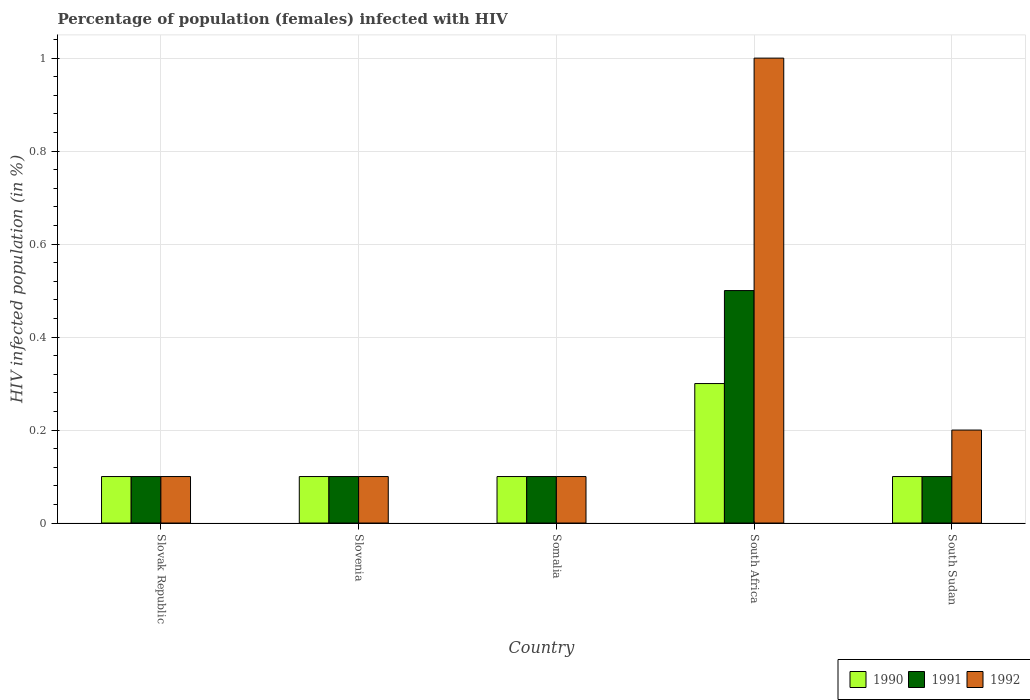How many bars are there on the 3rd tick from the right?
Offer a terse response. 3. What is the label of the 2nd group of bars from the left?
Your answer should be very brief. Slovenia. In how many cases, is the number of bars for a given country not equal to the number of legend labels?
Make the answer very short. 0. In which country was the percentage of HIV infected female population in 1991 maximum?
Your response must be concise. South Africa. In which country was the percentage of HIV infected female population in 1991 minimum?
Make the answer very short. Slovak Republic. What is the total percentage of HIV infected female population in 1992 in the graph?
Your answer should be compact. 1.5. What is the difference between the percentage of HIV infected female population in 1992 in Slovenia and that in South Sudan?
Provide a succinct answer. -0.1. What is the average percentage of HIV infected female population in 1991 per country?
Make the answer very short. 0.18. What is the difference between the percentage of HIV infected female population of/in 1991 and percentage of HIV infected female population of/in 1990 in Slovenia?
Make the answer very short. 0. Is the percentage of HIV infected female population in 1992 in Slovak Republic less than that in Somalia?
Your answer should be very brief. No. What is the difference between the highest and the second highest percentage of HIV infected female population in 1991?
Your response must be concise. 0.4. In how many countries, is the percentage of HIV infected female population in 1992 greater than the average percentage of HIV infected female population in 1992 taken over all countries?
Your response must be concise. 1. What does the 1st bar from the left in South Africa represents?
Provide a succinct answer. 1990. Is it the case that in every country, the sum of the percentage of HIV infected female population in 1991 and percentage of HIV infected female population in 1992 is greater than the percentage of HIV infected female population in 1990?
Offer a terse response. Yes. How many bars are there?
Your answer should be very brief. 15. Are all the bars in the graph horizontal?
Ensure brevity in your answer.  No. Does the graph contain any zero values?
Make the answer very short. No. Does the graph contain grids?
Keep it short and to the point. Yes. How many legend labels are there?
Your response must be concise. 3. What is the title of the graph?
Give a very brief answer. Percentage of population (females) infected with HIV. What is the label or title of the X-axis?
Provide a short and direct response. Country. What is the label or title of the Y-axis?
Your answer should be very brief. HIV infected population (in %). What is the HIV infected population (in %) in 1990 in Slovenia?
Keep it short and to the point. 0.1. What is the HIV infected population (in %) in 1991 in Slovenia?
Provide a succinct answer. 0.1. What is the HIV infected population (in %) in 1991 in Somalia?
Provide a short and direct response. 0.1. What is the HIV infected population (in %) of 1991 in South Africa?
Provide a succinct answer. 0.5. What is the HIV infected population (in %) of 1990 in South Sudan?
Provide a short and direct response. 0.1. What is the HIV infected population (in %) of 1992 in South Sudan?
Ensure brevity in your answer.  0.2. Across all countries, what is the maximum HIV infected population (in %) in 1990?
Make the answer very short. 0.3. What is the total HIV infected population (in %) in 1990 in the graph?
Provide a succinct answer. 0.7. What is the difference between the HIV infected population (in %) in 1990 in Slovak Republic and that in Slovenia?
Provide a short and direct response. 0. What is the difference between the HIV infected population (in %) of 1990 in Slovak Republic and that in South Africa?
Provide a short and direct response. -0.2. What is the difference between the HIV infected population (in %) in 1990 in Slovak Republic and that in South Sudan?
Make the answer very short. 0. What is the difference between the HIV infected population (in %) of 1991 in Slovak Republic and that in South Sudan?
Keep it short and to the point. 0. What is the difference between the HIV infected population (in %) of 1992 in Slovak Republic and that in South Sudan?
Your response must be concise. -0.1. What is the difference between the HIV infected population (in %) of 1992 in Slovenia and that in Somalia?
Ensure brevity in your answer.  0. What is the difference between the HIV infected population (in %) in 1990 in Slovenia and that in South Africa?
Your response must be concise. -0.2. What is the difference between the HIV infected population (in %) in 1991 in Slovenia and that in South Africa?
Keep it short and to the point. -0.4. What is the difference between the HIV infected population (in %) in 1990 in Slovenia and that in South Sudan?
Keep it short and to the point. 0. What is the difference between the HIV infected population (in %) of 1991 in Slovenia and that in South Sudan?
Give a very brief answer. 0. What is the difference between the HIV infected population (in %) of 1991 in Somalia and that in South Africa?
Provide a succinct answer. -0.4. What is the difference between the HIV infected population (in %) of 1992 in Somalia and that in South Africa?
Offer a very short reply. -0.9. What is the difference between the HIV infected population (in %) of 1990 in Somalia and that in South Sudan?
Give a very brief answer. 0. What is the difference between the HIV infected population (in %) in 1992 in Somalia and that in South Sudan?
Provide a short and direct response. -0.1. What is the difference between the HIV infected population (in %) of 1991 in South Africa and that in South Sudan?
Your answer should be compact. 0.4. What is the difference between the HIV infected population (in %) in 1990 in Slovak Republic and the HIV infected population (in %) in 1992 in Slovenia?
Your answer should be very brief. 0. What is the difference between the HIV infected population (in %) in 1991 in Slovak Republic and the HIV infected population (in %) in 1992 in Somalia?
Your response must be concise. 0. What is the difference between the HIV infected population (in %) of 1990 in Slovak Republic and the HIV infected population (in %) of 1992 in South Africa?
Your answer should be compact. -0.9. What is the difference between the HIV infected population (in %) in 1990 in Slovak Republic and the HIV infected population (in %) in 1992 in South Sudan?
Make the answer very short. -0.1. What is the difference between the HIV infected population (in %) of 1991 in Slovak Republic and the HIV infected population (in %) of 1992 in South Sudan?
Provide a succinct answer. -0.1. What is the difference between the HIV infected population (in %) of 1990 in Slovenia and the HIV infected population (in %) of 1991 in Somalia?
Offer a terse response. 0. What is the difference between the HIV infected population (in %) in 1990 in Slovenia and the HIV infected population (in %) in 1992 in South Africa?
Your answer should be very brief. -0.9. What is the difference between the HIV infected population (in %) of 1991 in Slovenia and the HIV infected population (in %) of 1992 in South Africa?
Offer a terse response. -0.9. What is the difference between the HIV infected population (in %) in 1990 in Slovenia and the HIV infected population (in %) in 1991 in South Sudan?
Make the answer very short. 0. What is the difference between the HIV infected population (in %) in 1990 in Somalia and the HIV infected population (in %) in 1991 in South Africa?
Provide a succinct answer. -0.4. What is the difference between the HIV infected population (in %) of 1990 in Somalia and the HIV infected population (in %) of 1991 in South Sudan?
Offer a very short reply. 0. What is the difference between the HIV infected population (in %) in 1990 in Somalia and the HIV infected population (in %) in 1992 in South Sudan?
Your response must be concise. -0.1. What is the difference between the HIV infected population (in %) of 1991 in Somalia and the HIV infected population (in %) of 1992 in South Sudan?
Provide a short and direct response. -0.1. What is the average HIV infected population (in %) of 1990 per country?
Your response must be concise. 0.14. What is the average HIV infected population (in %) in 1991 per country?
Provide a short and direct response. 0.18. What is the average HIV infected population (in %) of 1992 per country?
Provide a succinct answer. 0.3. What is the difference between the HIV infected population (in %) in 1990 and HIV infected population (in %) in 1991 in Slovak Republic?
Keep it short and to the point. 0. What is the difference between the HIV infected population (in %) of 1991 and HIV infected population (in %) of 1992 in Slovak Republic?
Your answer should be very brief. 0. What is the difference between the HIV infected population (in %) in 1990 and HIV infected population (in %) in 1991 in Slovenia?
Your answer should be very brief. 0. What is the difference between the HIV infected population (in %) of 1990 and HIV infected population (in %) of 1991 in South Africa?
Your answer should be compact. -0.2. What is the difference between the HIV infected population (in %) of 1990 and HIV infected population (in %) of 1992 in South Africa?
Keep it short and to the point. -0.7. What is the difference between the HIV infected population (in %) of 1991 and HIV infected population (in %) of 1992 in South Africa?
Your answer should be very brief. -0.5. What is the difference between the HIV infected population (in %) in 1991 and HIV infected population (in %) in 1992 in South Sudan?
Offer a terse response. -0.1. What is the ratio of the HIV infected population (in %) in 1992 in Slovak Republic to that in Slovenia?
Offer a terse response. 1. What is the ratio of the HIV infected population (in %) in 1990 in Slovak Republic to that in Somalia?
Offer a terse response. 1. What is the ratio of the HIV infected population (in %) of 1992 in Slovak Republic to that in Somalia?
Your answer should be compact. 1. What is the ratio of the HIV infected population (in %) in 1990 in Slovak Republic to that in South Africa?
Your answer should be compact. 0.33. What is the ratio of the HIV infected population (in %) of 1991 in Slovak Republic to that in South Africa?
Make the answer very short. 0.2. What is the ratio of the HIV infected population (in %) in 1992 in Slovak Republic to that in South Africa?
Your response must be concise. 0.1. What is the ratio of the HIV infected population (in %) of 1991 in Slovak Republic to that in South Sudan?
Provide a succinct answer. 1. What is the ratio of the HIV infected population (in %) of 1990 in Slovenia to that in Somalia?
Give a very brief answer. 1. What is the ratio of the HIV infected population (in %) in 1992 in Slovenia to that in Somalia?
Your answer should be compact. 1. What is the ratio of the HIV infected population (in %) of 1990 in Slovenia to that in South Africa?
Keep it short and to the point. 0.33. What is the ratio of the HIV infected population (in %) of 1991 in Slovenia to that in South Sudan?
Make the answer very short. 1. What is the ratio of the HIV infected population (in %) of 1990 in Somalia to that in South Africa?
Provide a succinct answer. 0.33. What is the ratio of the HIV infected population (in %) of 1991 in Somalia to that in South Africa?
Ensure brevity in your answer.  0.2. What is the ratio of the HIV infected population (in %) in 1990 in South Africa to that in South Sudan?
Your response must be concise. 3. What is the ratio of the HIV infected population (in %) of 1992 in South Africa to that in South Sudan?
Your answer should be very brief. 5. What is the difference between the highest and the second highest HIV infected population (in %) of 1992?
Provide a succinct answer. 0.8. What is the difference between the highest and the lowest HIV infected population (in %) in 1990?
Give a very brief answer. 0.2. 